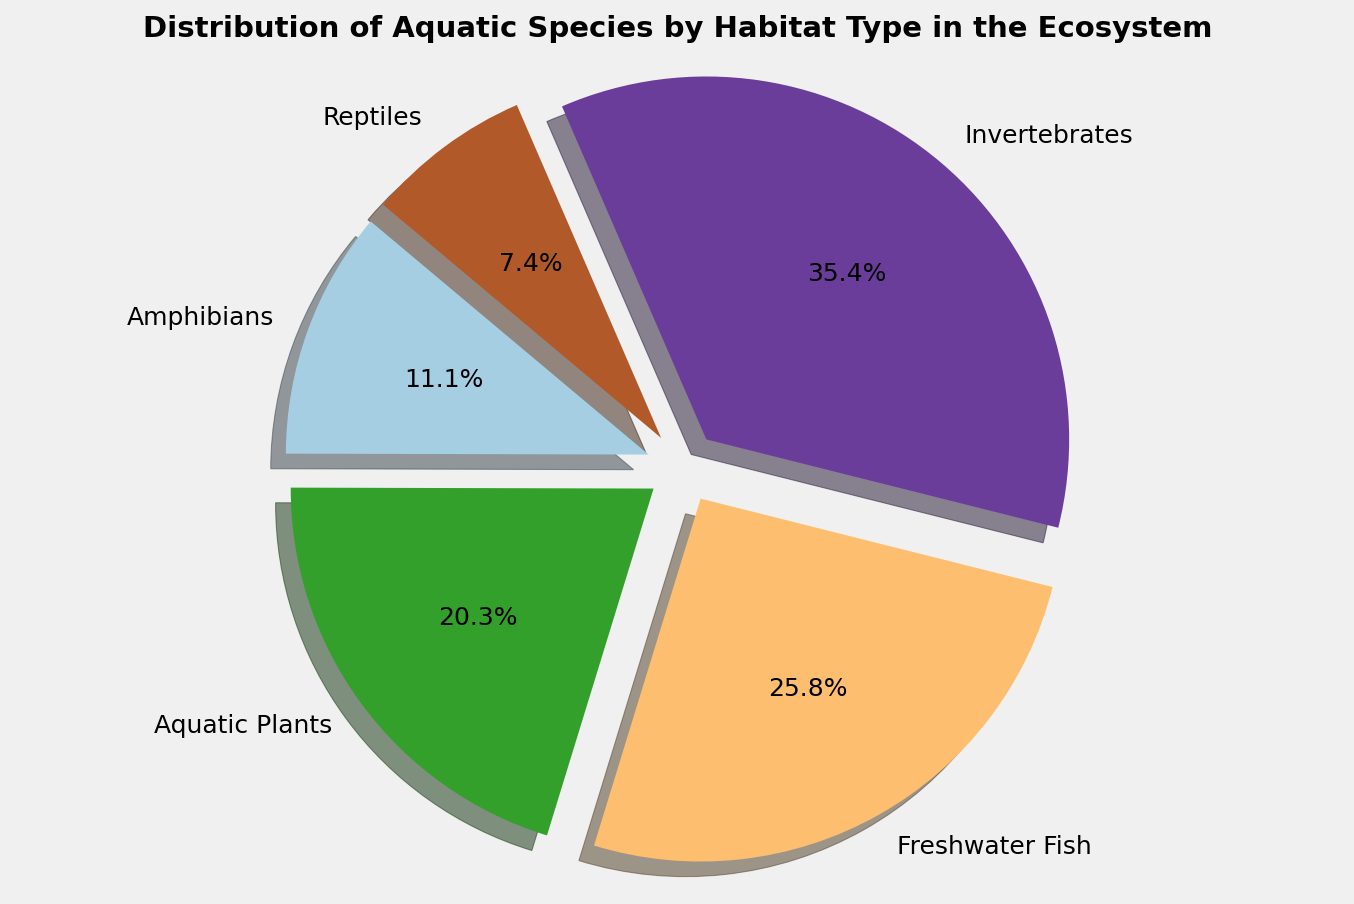Which habitat type contains the largest proportion of aquatic species? Look at the pie chart and identify the largest slice. The label associated with this slice indicates the habitat type with the largest proportion.
Answer: Ponds Which habitat type constitutes the smallest proportion of aquatic species? Identify the smallest slice in the pie chart. The label for this slice represents the habitat type with the smallest proportion.
Answer: Streams Compare the proportions of aquatic species in Ponds and Lakes. Which has more, and by what percentage? Examine the sizes of the slices for Ponds and Lakes and check the percentage labels. Subtract the percentage of Lakes from the percentage of Ponds.
Answer: Ponds, difference of 19.9% What is the combined proportion of aquatic species in Rivers and Swamps? Find the slices labeled Rivers and Swamps, then add their percentages together to get the total proportion.
Answer: 25.1% What visual feature helps to quickly identify the habitat types with the largest and smallest proportions? The slices are exploded to draw attention, making it easy to visually distinguish the largest and smallest proportions. The exploded larger slice is the largest proportion, and the smaller exploded slice is the smallest proportion.
Answer: Exploded slices If we combine the proportions of Ponds and Lakes, what fraction of the total pie will this combination represent? Add the percentages of Ponds and Lakes. Convert this sum to a fraction of the whole pie (out of 100).
Answer: 46.6% Which habitat type other than Ponds and Lakes has a significant proportion of aquatic species? Look for the next largest slice after Ponds and Lakes. This slice represents another habitat type with a notable proportion.
Answer: Streams What visual clue indicates the starting point of the pie chart, and how does it help in reading the chart? The starting point is marked by the first slice (at the 140-degree angle) from the horizontal axis, helping to organize the order of habitat types around the pie.
Answer: Starting angle at 140 degrees Calculate the difference in proportions between Streams and Swamps. Subtract the percentage of Swamps from the percentage of Streams to find the difference.
Answer: 3.2% 